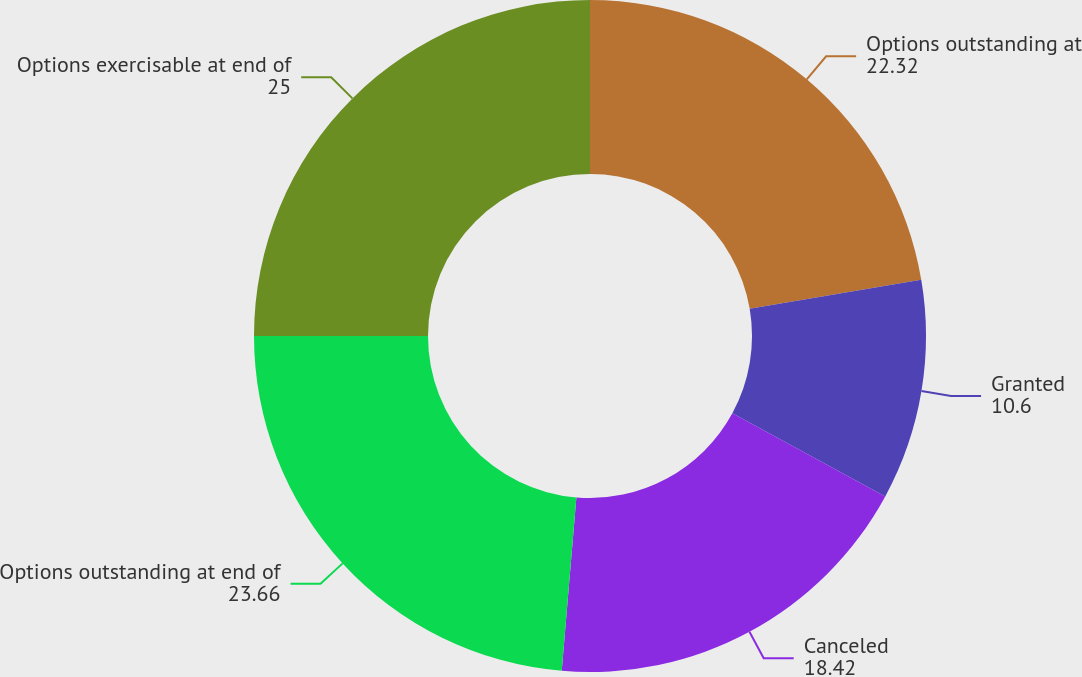Convert chart to OTSL. <chart><loc_0><loc_0><loc_500><loc_500><pie_chart><fcel>Options outstanding at<fcel>Granted<fcel>Canceled<fcel>Options outstanding at end of<fcel>Options exercisable at end of<nl><fcel>22.32%<fcel>10.6%<fcel>18.42%<fcel>23.66%<fcel>25.0%<nl></chart> 